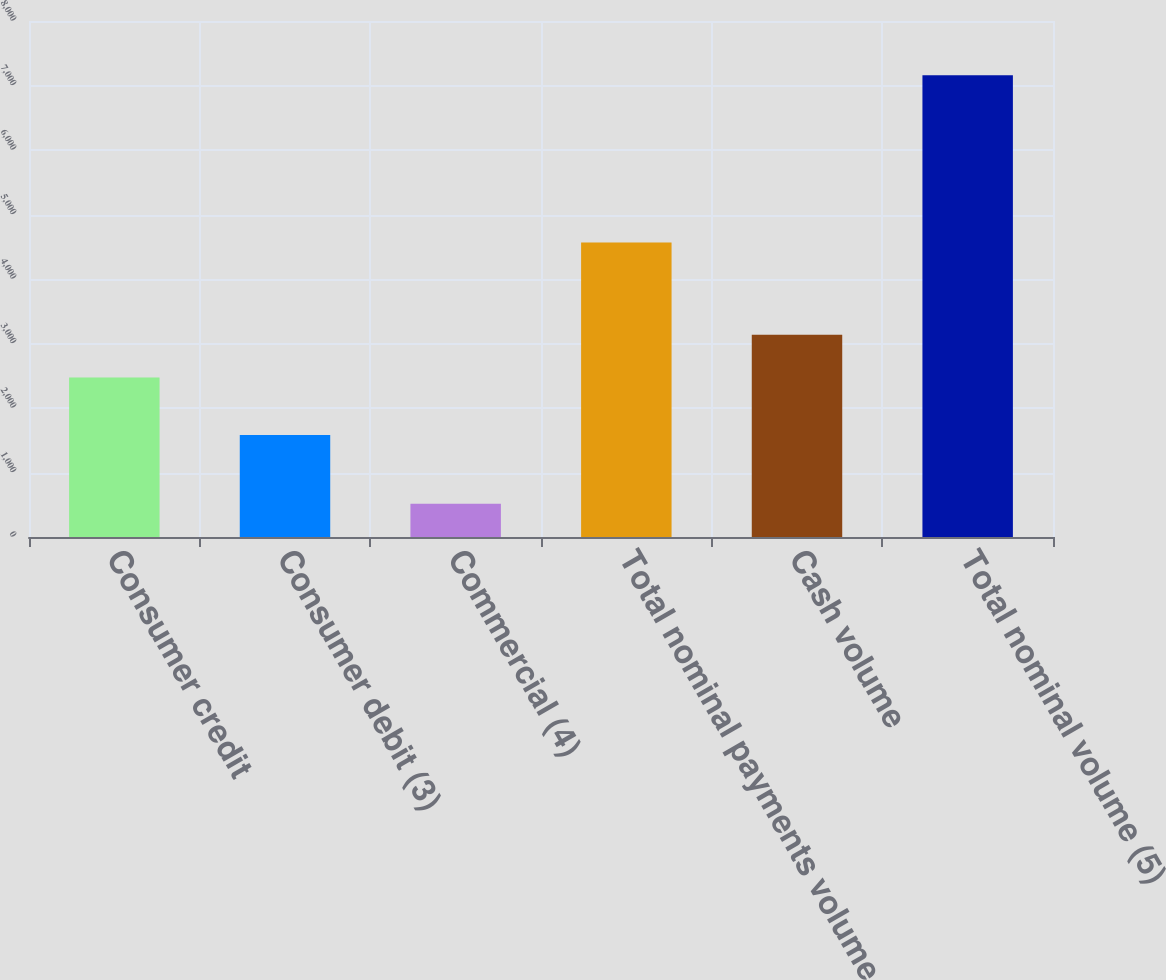Convert chart to OTSL. <chart><loc_0><loc_0><loc_500><loc_500><bar_chart><fcel>Consumer credit<fcel>Consumer debit (3)<fcel>Commercial (4)<fcel>Total nominal payments volume<fcel>Cash volume<fcel>Total nominal volume (5)<nl><fcel>2471<fcel>1581<fcel>515<fcel>4567<fcel>3135.2<fcel>7157<nl></chart> 